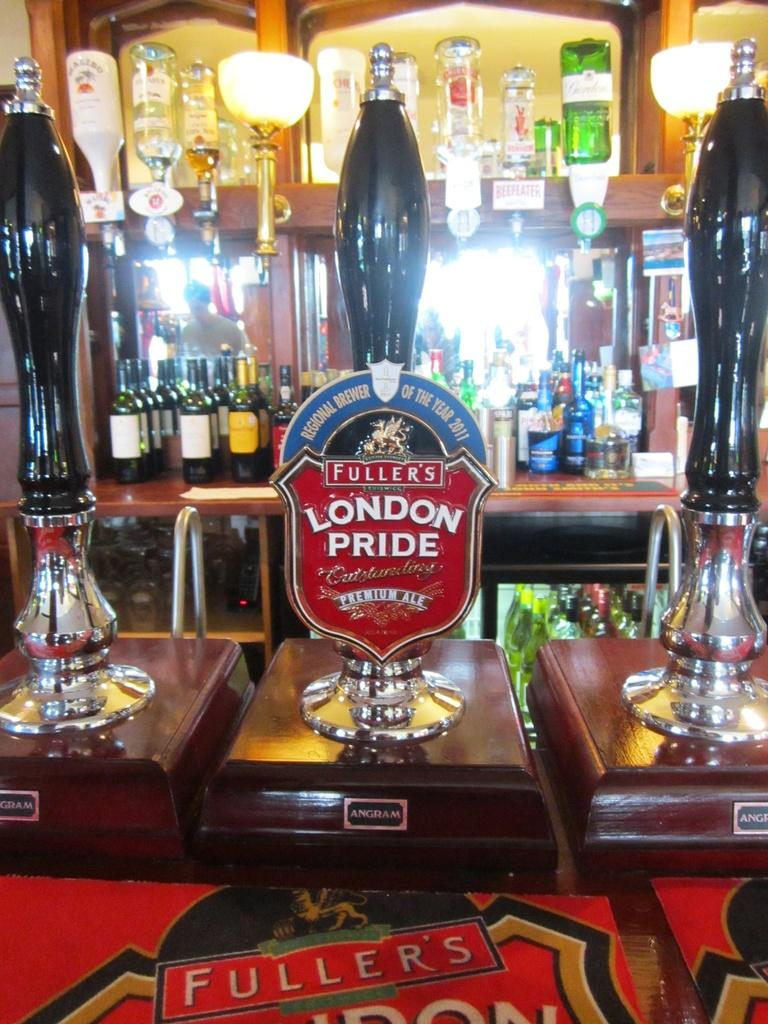<image>
Write a terse but informative summary of the picture. A beer tap in a bar says Fuller's London Pride. 